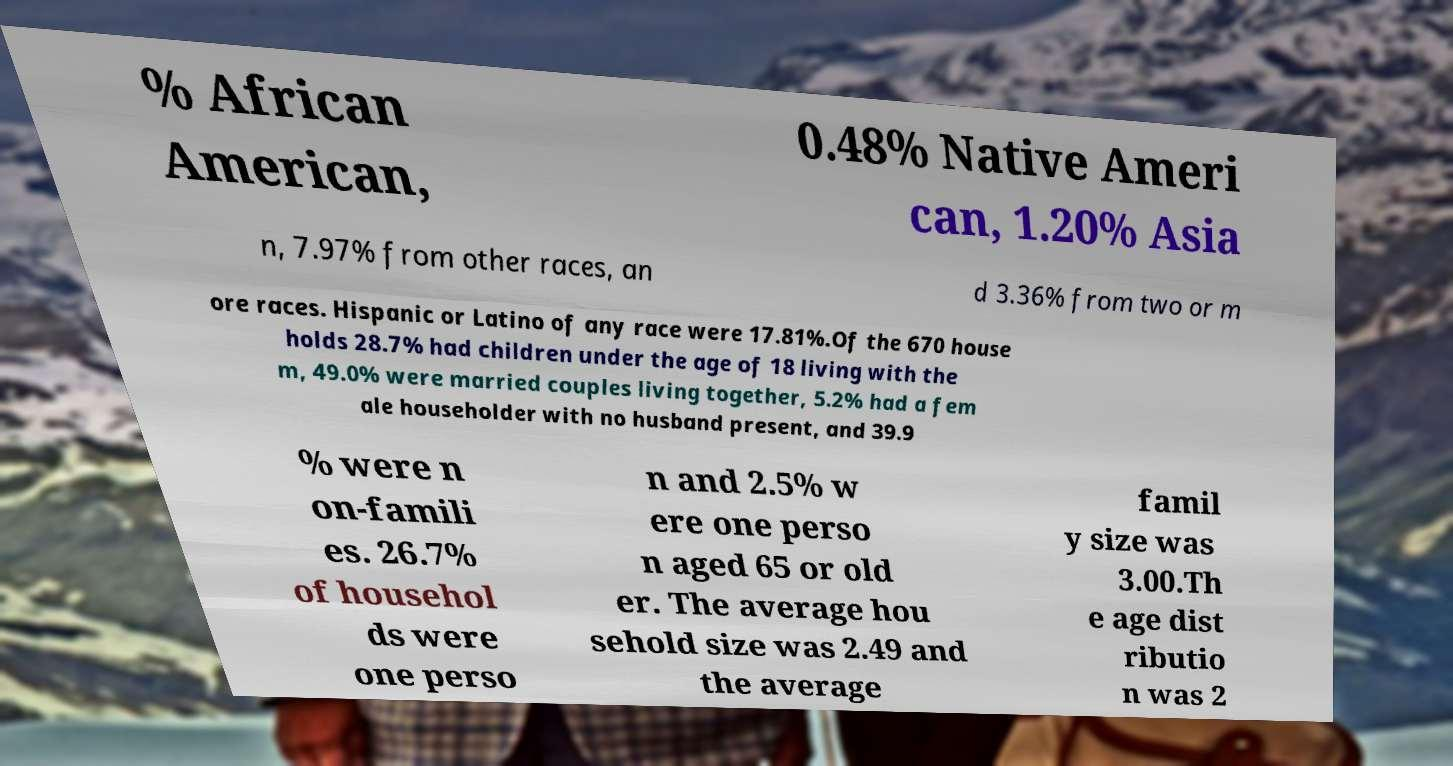For documentation purposes, I need the text within this image transcribed. Could you provide that? % African American, 0.48% Native Ameri can, 1.20% Asia n, 7.97% from other races, an d 3.36% from two or m ore races. Hispanic or Latino of any race were 17.81%.Of the 670 house holds 28.7% had children under the age of 18 living with the m, 49.0% were married couples living together, 5.2% had a fem ale householder with no husband present, and 39.9 % were n on-famili es. 26.7% of househol ds were one perso n and 2.5% w ere one perso n aged 65 or old er. The average hou sehold size was 2.49 and the average famil y size was 3.00.Th e age dist ributio n was 2 